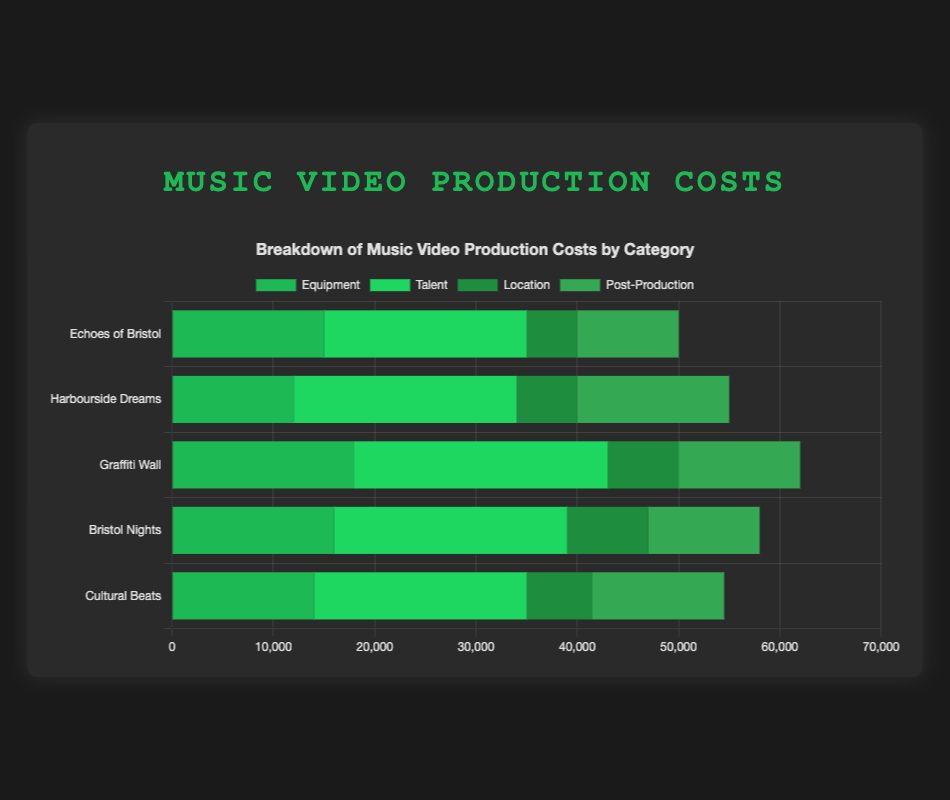Which music video has the highest cost for talent? By examining the bar lengths for the Talent category, we see that "Graffiti Wall" has the longest bar in the Talent category, indicating it spent the most on talent.
Answer: Graffiti Wall Which music video has the lowest location cost? The bar lengths for the Location category show that "Echoes of Bristol" has the shortest bar, indicating the lowest cost for location.
Answer: Echoes of Bristol What is the total cost for producing "Harbourside Dreams"? Sum the costs for each category: Equipment (12000) + Talent (22000) + Location (6000) + Post-Production (15000) = 55000.
Answer: 55000 How does the equipment cost for "Cultural Beats" compare to the equipment cost for "Bristol Nights"? Compare the bar lengths for Equipment. "Bristol Nights" (16000) has a longer bar than "Cultural Beats" (14000).
Answer: Bristol Nights > Cultural Beats Which category generally incurs the highest costs across all music videos? By comparing the sum of the bars for each category, it is evident that Talent usually incurs the highest costs since its bars are generally the longest.
Answer: Talent What's the average cost of post-production across all music videos? Sum the post-production costs: 10000 + 15000 + 12000 + 11000 + 13000 = 61000. Divide by the number of videos (5). 61000 / 5 = 12200.
Answer: 12200 Which music video has a lower talent cost: "Harbourside Dreams" or "Bristol Nights"? Compare the bars for the Talent category. "Harbourside Dreams" (22000) has a lower talent cost than "Bristol Nights" (23000).
Answer: Harbourside Dreams What is the combined location cost for "Echoes of Bristol" and "Graffiti Wall"? Add the location costs: 5000 (Echoes of Bristol) + 7000 (Graffiti Wall) = 12000.
Answer: 12000 How much more was spent on equipment for "Graffiti Wall" than "Harbourside Dreams"? Subtract the equipment costs: 18000 (Graffiti Wall) - 12000 (Harbourside Dreams) = 6000.
Answer: 6000 Which categories have different cost allocations but similar overall costs for "Bristol Nights" and "Cultural Beats"? Compare the category bars of the two videos. Equipment: 16000 vs 14000, Talent: 23000 vs 21000, Location: 8000 vs 6500, Post-Production: 11000 vs 13000. Despite differences, their total costs are comparable.
Answer: Various categories 